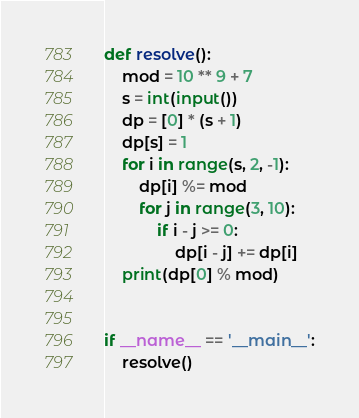Convert code to text. <code><loc_0><loc_0><loc_500><loc_500><_Python_>def resolve():
    mod = 10 ** 9 + 7
    s = int(input())
    dp = [0] * (s + 1)
    dp[s] = 1
    for i in range(s, 2, -1):
        dp[i] %= mod
        for j in range(3, 10):
            if i - j >= 0:
                dp[i - j] += dp[i]
    print(dp[0] % mod)


if __name__ == '__main__':
    resolve()
</code> 